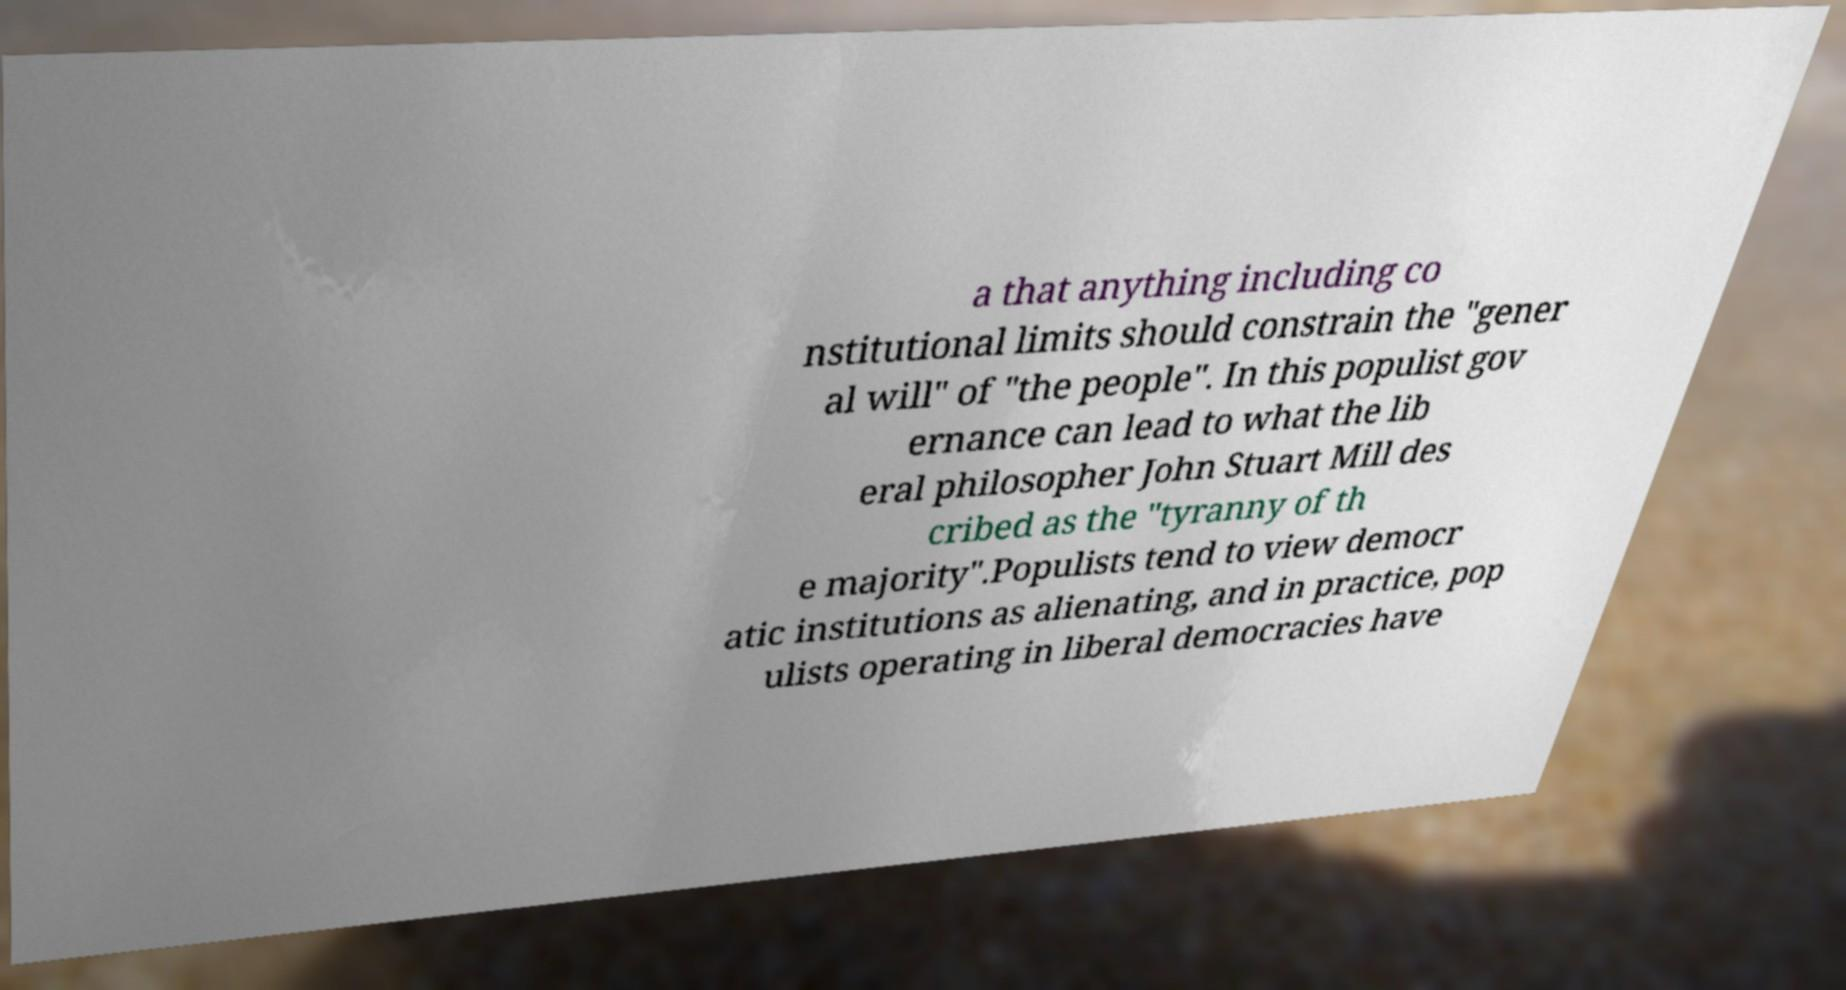Please identify and transcribe the text found in this image. a that anything including co nstitutional limits should constrain the "gener al will" of "the people". In this populist gov ernance can lead to what the lib eral philosopher John Stuart Mill des cribed as the "tyranny of th e majority".Populists tend to view democr atic institutions as alienating, and in practice, pop ulists operating in liberal democracies have 